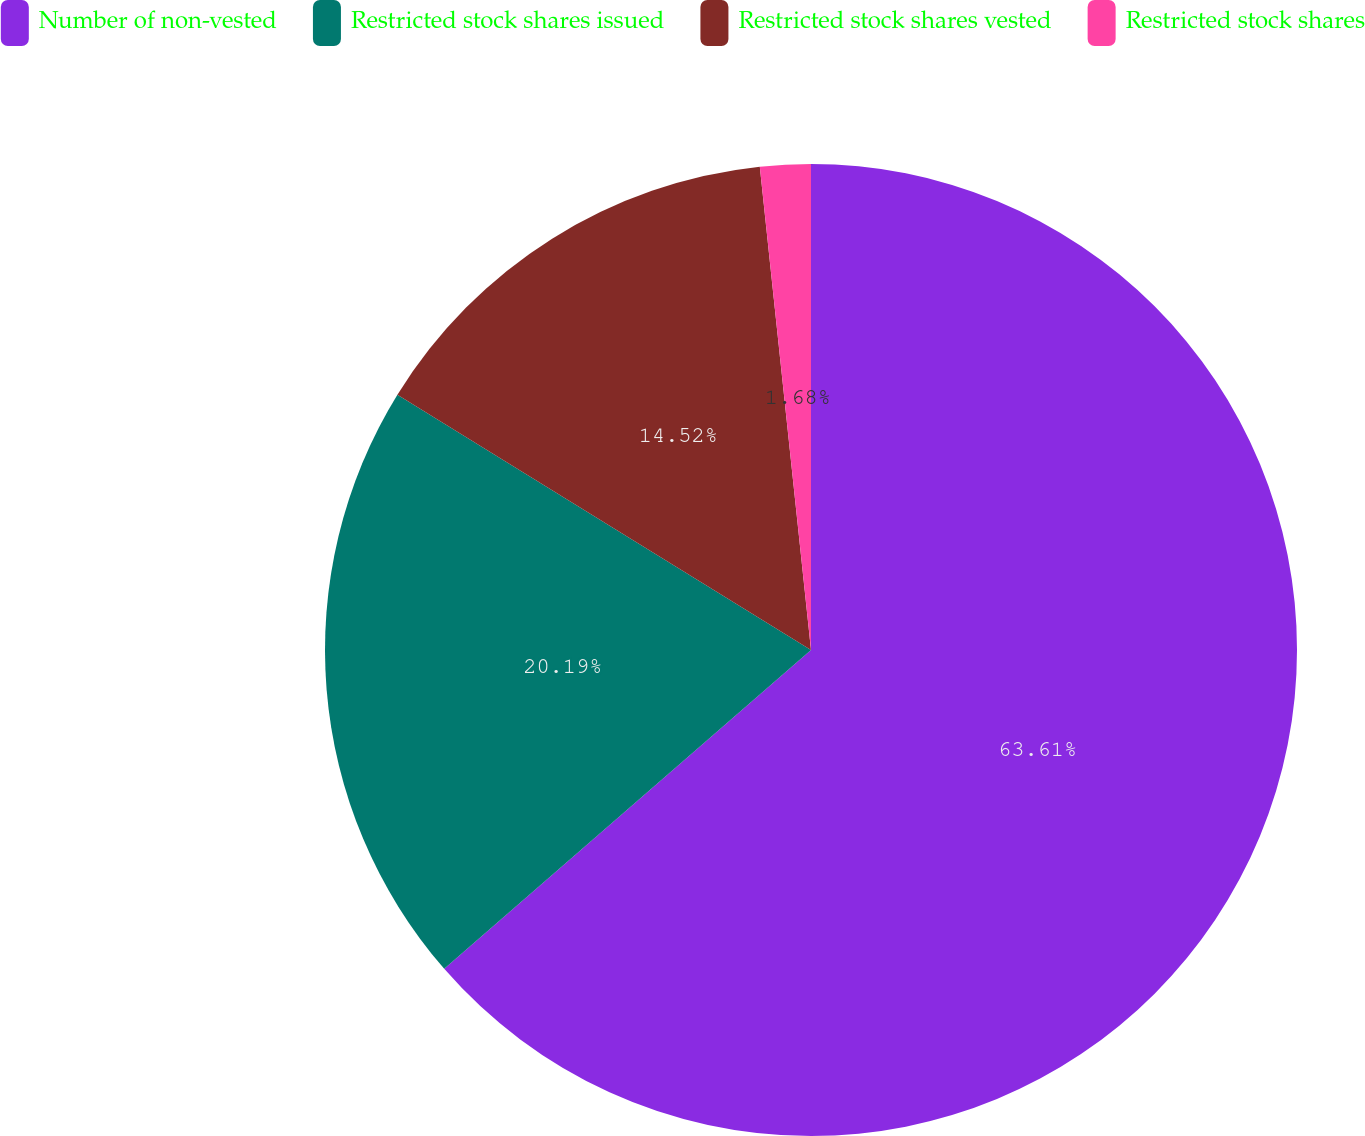Convert chart to OTSL. <chart><loc_0><loc_0><loc_500><loc_500><pie_chart><fcel>Number of non-vested<fcel>Restricted stock shares issued<fcel>Restricted stock shares vested<fcel>Restricted stock shares<nl><fcel>63.61%<fcel>20.19%<fcel>14.52%<fcel>1.68%<nl></chart> 